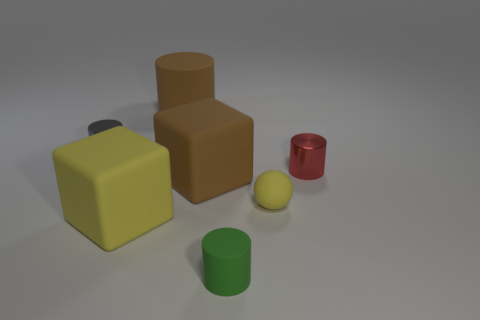Are there an equal number of small cylinders that are behind the small red cylinder and big yellow blocks?
Your answer should be very brief. Yes. There is a green matte thing that is the same shape as the red metal thing; what is its size?
Keep it short and to the point. Small. Do the big yellow thing and the small gray thing that is behind the tiny yellow matte thing have the same shape?
Your response must be concise. No. What size is the gray cylinder that is to the left of the rubber thing behind the gray metallic cylinder?
Offer a very short reply. Small. Are there an equal number of yellow cubes that are behind the tiny yellow rubber object and small metal things in front of the green matte object?
Provide a short and direct response. Yes. What color is the big matte thing that is the same shape as the gray shiny object?
Offer a terse response. Brown. What number of things have the same color as the matte ball?
Keep it short and to the point. 1. There is a yellow thing that is left of the tiny green cylinder; is it the same shape as the small gray object?
Provide a short and direct response. No. What is the shape of the red thing that is to the right of the big matte cube left of the matte cylinder that is behind the tiny gray thing?
Provide a succinct answer. Cylinder. The green cylinder is what size?
Give a very brief answer. Small. 